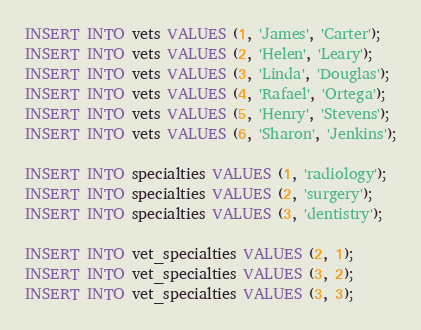<code> <loc_0><loc_0><loc_500><loc_500><_SQL_>INSERT INTO vets VALUES (1, 'James', 'Carter');
INSERT INTO vets VALUES (2, 'Helen', 'Leary');
INSERT INTO vets VALUES (3, 'Linda', 'Douglas');
INSERT INTO vets VALUES (4, 'Rafael', 'Ortega');
INSERT INTO vets VALUES (5, 'Henry', 'Stevens');
INSERT INTO vets VALUES (6, 'Sharon', 'Jenkins');

INSERT INTO specialties VALUES (1, 'radiology');
INSERT INTO specialties VALUES (2, 'surgery');
INSERT INTO specialties VALUES (3, 'dentistry');

INSERT INTO vet_specialties VALUES (2, 1);
INSERT INTO vet_specialties VALUES (3, 2);
INSERT INTO vet_specialties VALUES (3, 3);</code> 